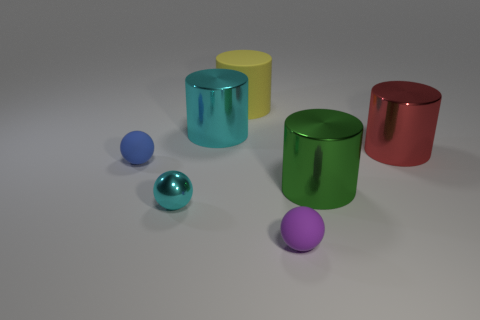Subtract 1 cylinders. How many cylinders are left? 3 Add 1 large brown cylinders. How many objects exist? 8 Subtract all spheres. How many objects are left? 4 Add 5 small cyan cylinders. How many small cyan cylinders exist? 5 Subtract 1 cyan cylinders. How many objects are left? 6 Subtract all big balls. Subtract all blue rubber balls. How many objects are left? 6 Add 7 rubber objects. How many rubber objects are left? 10 